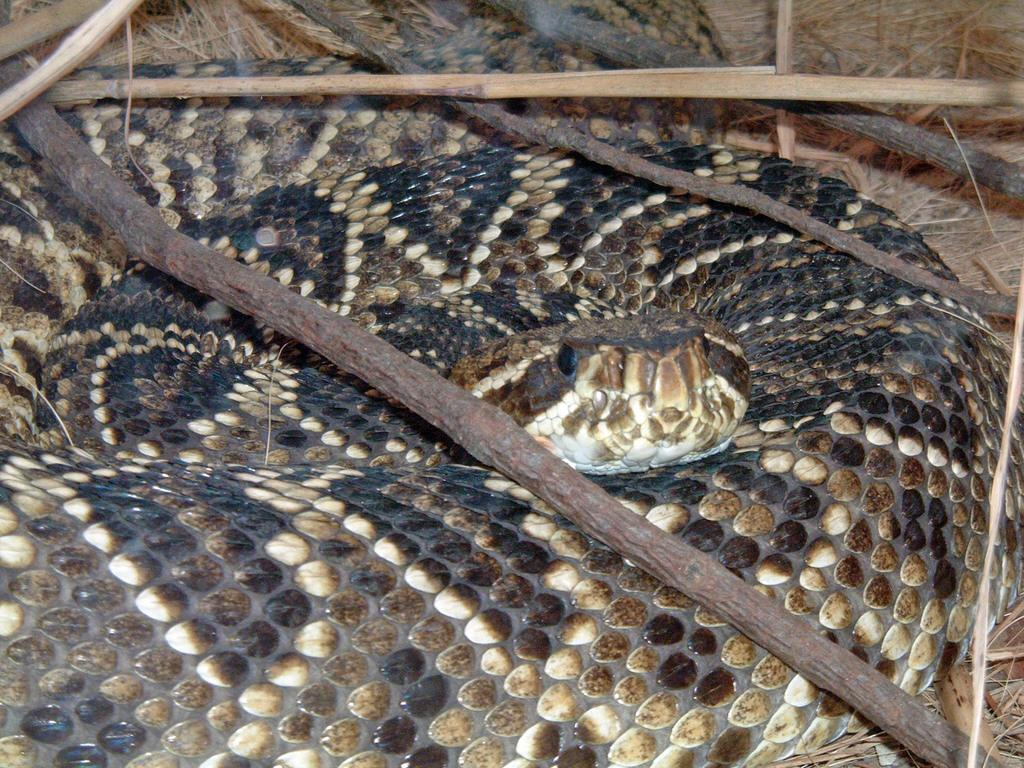What animal is present in the picture? There is a snake in the picture. What is located above the snake? There are stocks above the snake. What type of vegetation can be seen at the bottom of the picture? There is grass at the bottom of the picture. What type of honey can be seen dripping from the edge of the picture? There is no honey present in the image, nor is there any dripping from the edge of the picture. 